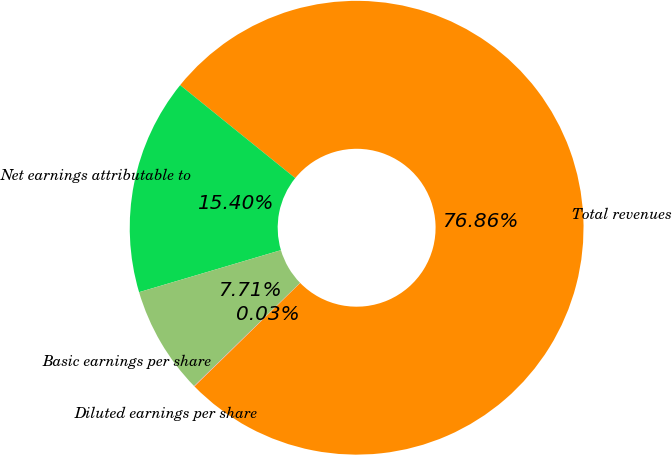<chart> <loc_0><loc_0><loc_500><loc_500><pie_chart><fcel>Total revenues<fcel>Net earnings attributable to<fcel>Basic earnings per share<fcel>Diluted earnings per share<nl><fcel>76.86%<fcel>15.4%<fcel>7.71%<fcel>0.03%<nl></chart> 